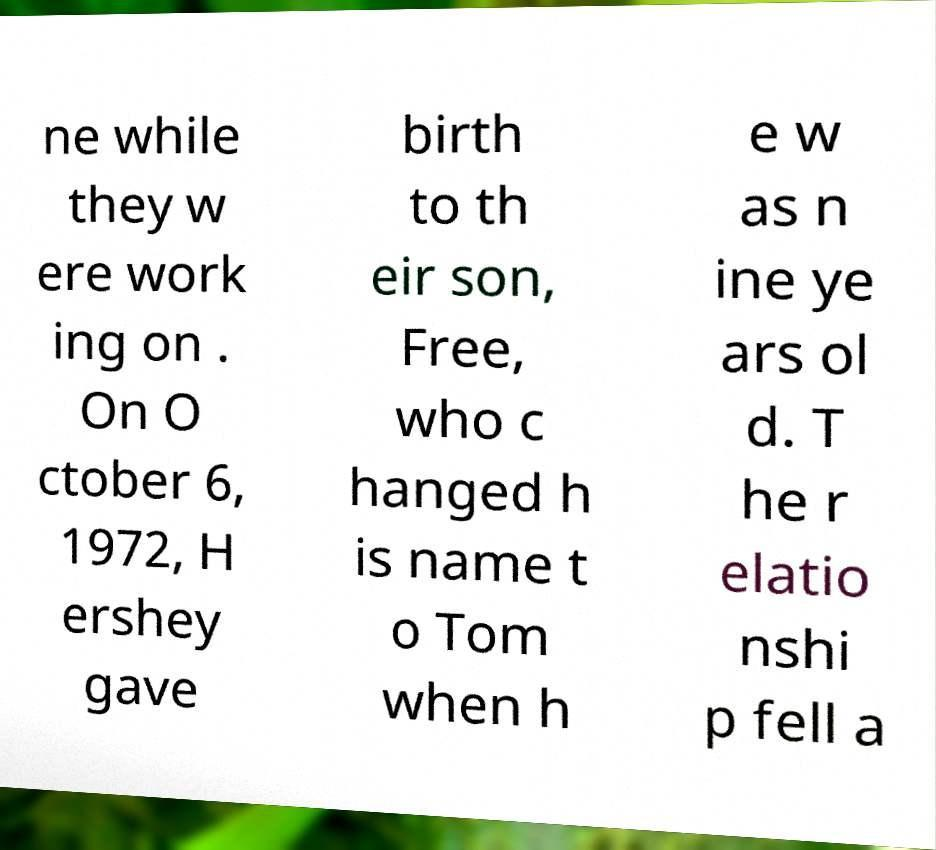Can you read and provide the text displayed in the image?This photo seems to have some interesting text. Can you extract and type it out for me? ne while they w ere work ing on . On O ctober 6, 1972, H ershey gave birth to th eir son, Free, who c hanged h is name t o Tom when h e w as n ine ye ars ol d. T he r elatio nshi p fell a 